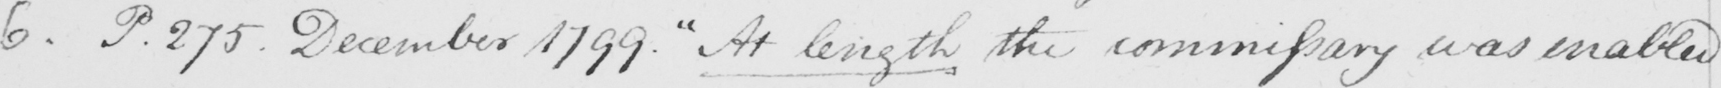Transcribe the text shown in this historical manuscript line. 6 . P.275 December 1799 .  " At length the commissary was enabled 